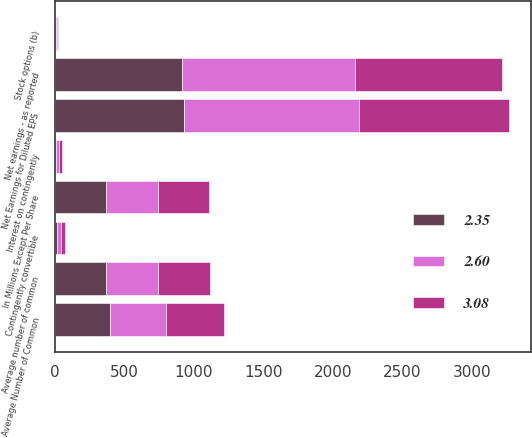Convert chart to OTSL. <chart><loc_0><loc_0><loc_500><loc_500><stacked_bar_chart><ecel><fcel>In Millions Except Per Share<fcel>Net earnings - as reported<fcel>Interest on contingently<fcel>Net Earnings for Diluted EPS<fcel>Average number of common<fcel>Stock options (b)<fcel>Contingently convertible<fcel>Average Number of Common<nl><fcel>2.6<fcel>371<fcel>1240<fcel>20<fcel>1260<fcel>371<fcel>8<fcel>29<fcel>409<nl><fcel>3.08<fcel>371<fcel>1055<fcel>20<fcel>1075<fcel>375<fcel>8<fcel>29<fcel>413<nl><fcel>2.35<fcel>371<fcel>917<fcel>11<fcel>928<fcel>369<fcel>9<fcel>17<fcel>395<nl></chart> 